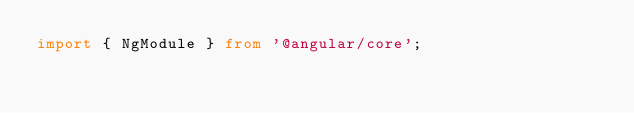Convert code to text. <code><loc_0><loc_0><loc_500><loc_500><_TypeScript_>import { NgModule } from '@angular/core';</code> 